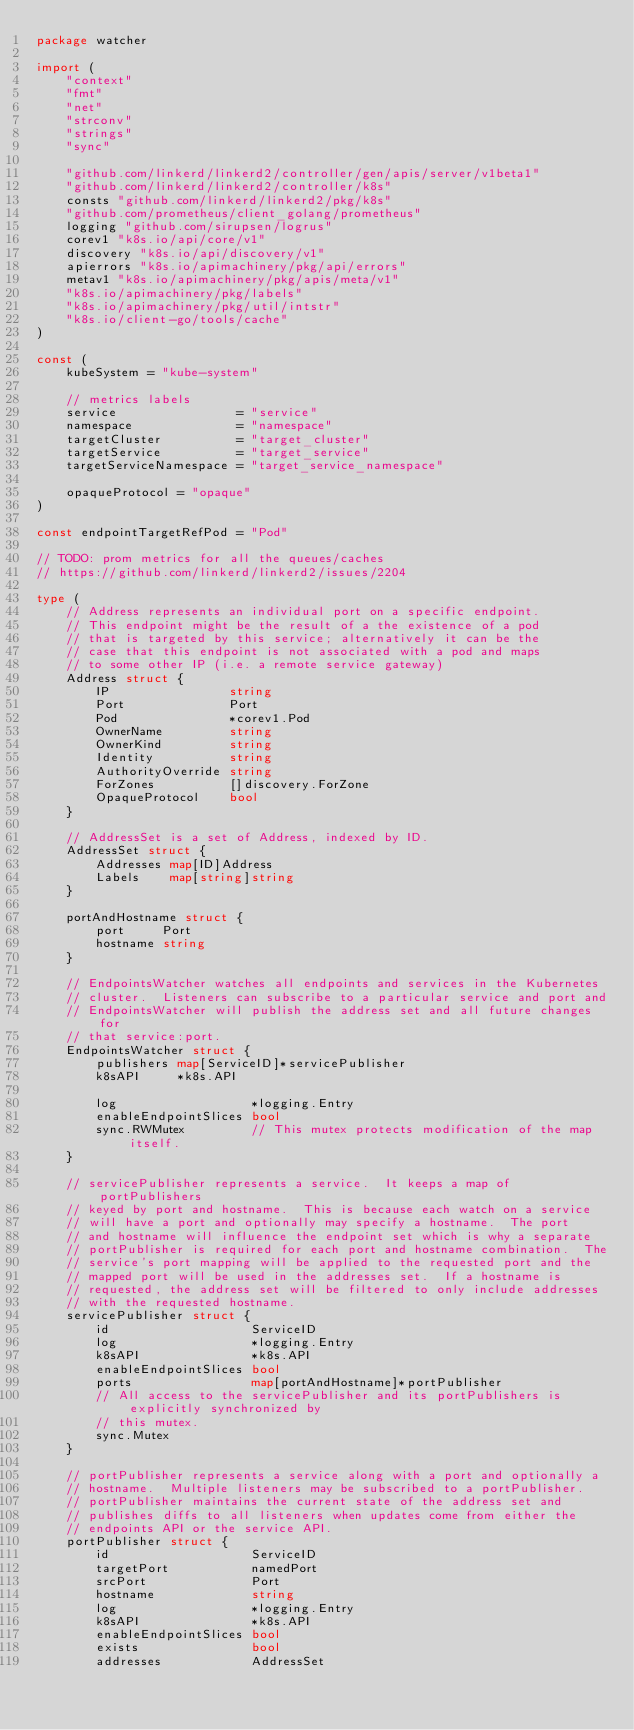Convert code to text. <code><loc_0><loc_0><loc_500><loc_500><_Go_>package watcher

import (
	"context"
	"fmt"
	"net"
	"strconv"
	"strings"
	"sync"

	"github.com/linkerd/linkerd2/controller/gen/apis/server/v1beta1"
	"github.com/linkerd/linkerd2/controller/k8s"
	consts "github.com/linkerd/linkerd2/pkg/k8s"
	"github.com/prometheus/client_golang/prometheus"
	logging "github.com/sirupsen/logrus"
	corev1 "k8s.io/api/core/v1"
	discovery "k8s.io/api/discovery/v1"
	apierrors "k8s.io/apimachinery/pkg/api/errors"
	metav1 "k8s.io/apimachinery/pkg/apis/meta/v1"
	"k8s.io/apimachinery/pkg/labels"
	"k8s.io/apimachinery/pkg/util/intstr"
	"k8s.io/client-go/tools/cache"
)

const (
	kubeSystem = "kube-system"

	// metrics labels
	service                = "service"
	namespace              = "namespace"
	targetCluster          = "target_cluster"
	targetService          = "target_service"
	targetServiceNamespace = "target_service_namespace"

	opaqueProtocol = "opaque"
)

const endpointTargetRefPod = "Pod"

// TODO: prom metrics for all the queues/caches
// https://github.com/linkerd/linkerd2/issues/2204

type (
	// Address represents an individual port on a specific endpoint.
	// This endpoint might be the result of a the existence of a pod
	// that is targeted by this service; alternatively it can be the
	// case that this endpoint is not associated with a pod and maps
	// to some other IP (i.e. a remote service gateway)
	Address struct {
		IP                string
		Port              Port
		Pod               *corev1.Pod
		OwnerName         string
		OwnerKind         string
		Identity          string
		AuthorityOverride string
		ForZones          []discovery.ForZone
		OpaqueProtocol    bool
	}

	// AddressSet is a set of Address, indexed by ID.
	AddressSet struct {
		Addresses map[ID]Address
		Labels    map[string]string
	}

	portAndHostname struct {
		port     Port
		hostname string
	}

	// EndpointsWatcher watches all endpoints and services in the Kubernetes
	// cluster.  Listeners can subscribe to a particular service and port and
	// EndpointsWatcher will publish the address set and all future changes for
	// that service:port.
	EndpointsWatcher struct {
		publishers map[ServiceID]*servicePublisher
		k8sAPI     *k8s.API

		log                  *logging.Entry
		enableEndpointSlices bool
		sync.RWMutex         // This mutex protects modification of the map itself.
	}

	// servicePublisher represents a service.  It keeps a map of portPublishers
	// keyed by port and hostname.  This is because each watch on a service
	// will have a port and optionally may specify a hostname.  The port
	// and hostname will influence the endpoint set which is why a separate
	// portPublisher is required for each port and hostname combination.  The
	// service's port mapping will be applied to the requested port and the
	// mapped port will be used in the addresses set.  If a hostname is
	// requested, the address set will be filtered to only include addresses
	// with the requested hostname.
	servicePublisher struct {
		id                   ServiceID
		log                  *logging.Entry
		k8sAPI               *k8s.API
		enableEndpointSlices bool
		ports                map[portAndHostname]*portPublisher
		// All access to the servicePublisher and its portPublishers is explicitly synchronized by
		// this mutex.
		sync.Mutex
	}

	// portPublisher represents a service along with a port and optionally a
	// hostname.  Multiple listeners may be subscribed to a portPublisher.
	// portPublisher maintains the current state of the address set and
	// publishes diffs to all listeners when updates come from either the
	// endpoints API or the service API.
	portPublisher struct {
		id                   ServiceID
		targetPort           namedPort
		srcPort              Port
		hostname             string
		log                  *logging.Entry
		k8sAPI               *k8s.API
		enableEndpointSlices bool
		exists               bool
		addresses            AddressSet</code> 